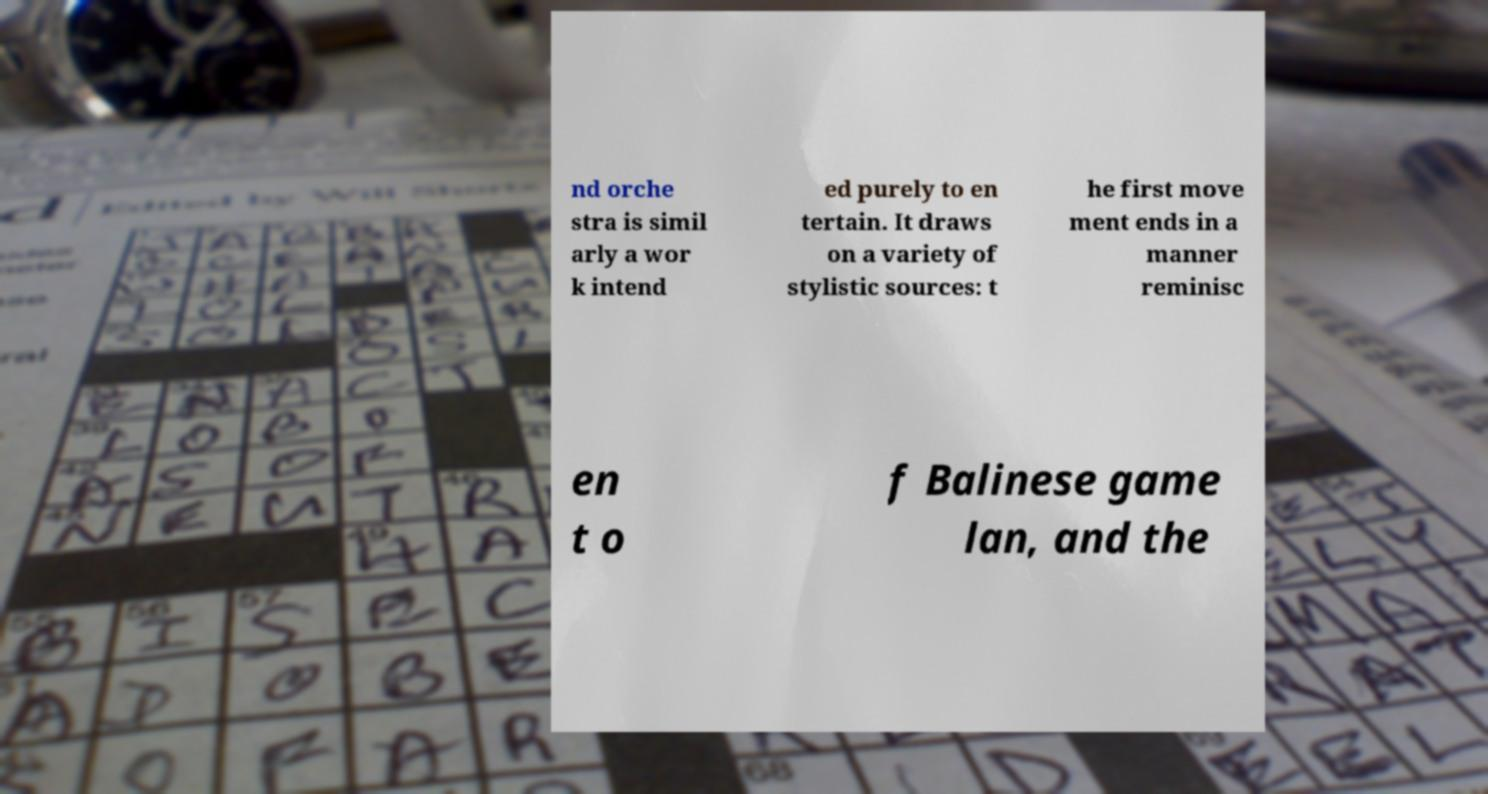Can you accurately transcribe the text from the provided image for me? nd orche stra is simil arly a wor k intend ed purely to en tertain. It draws on a variety of stylistic sources: t he first move ment ends in a manner reminisc en t o f Balinese game lan, and the 